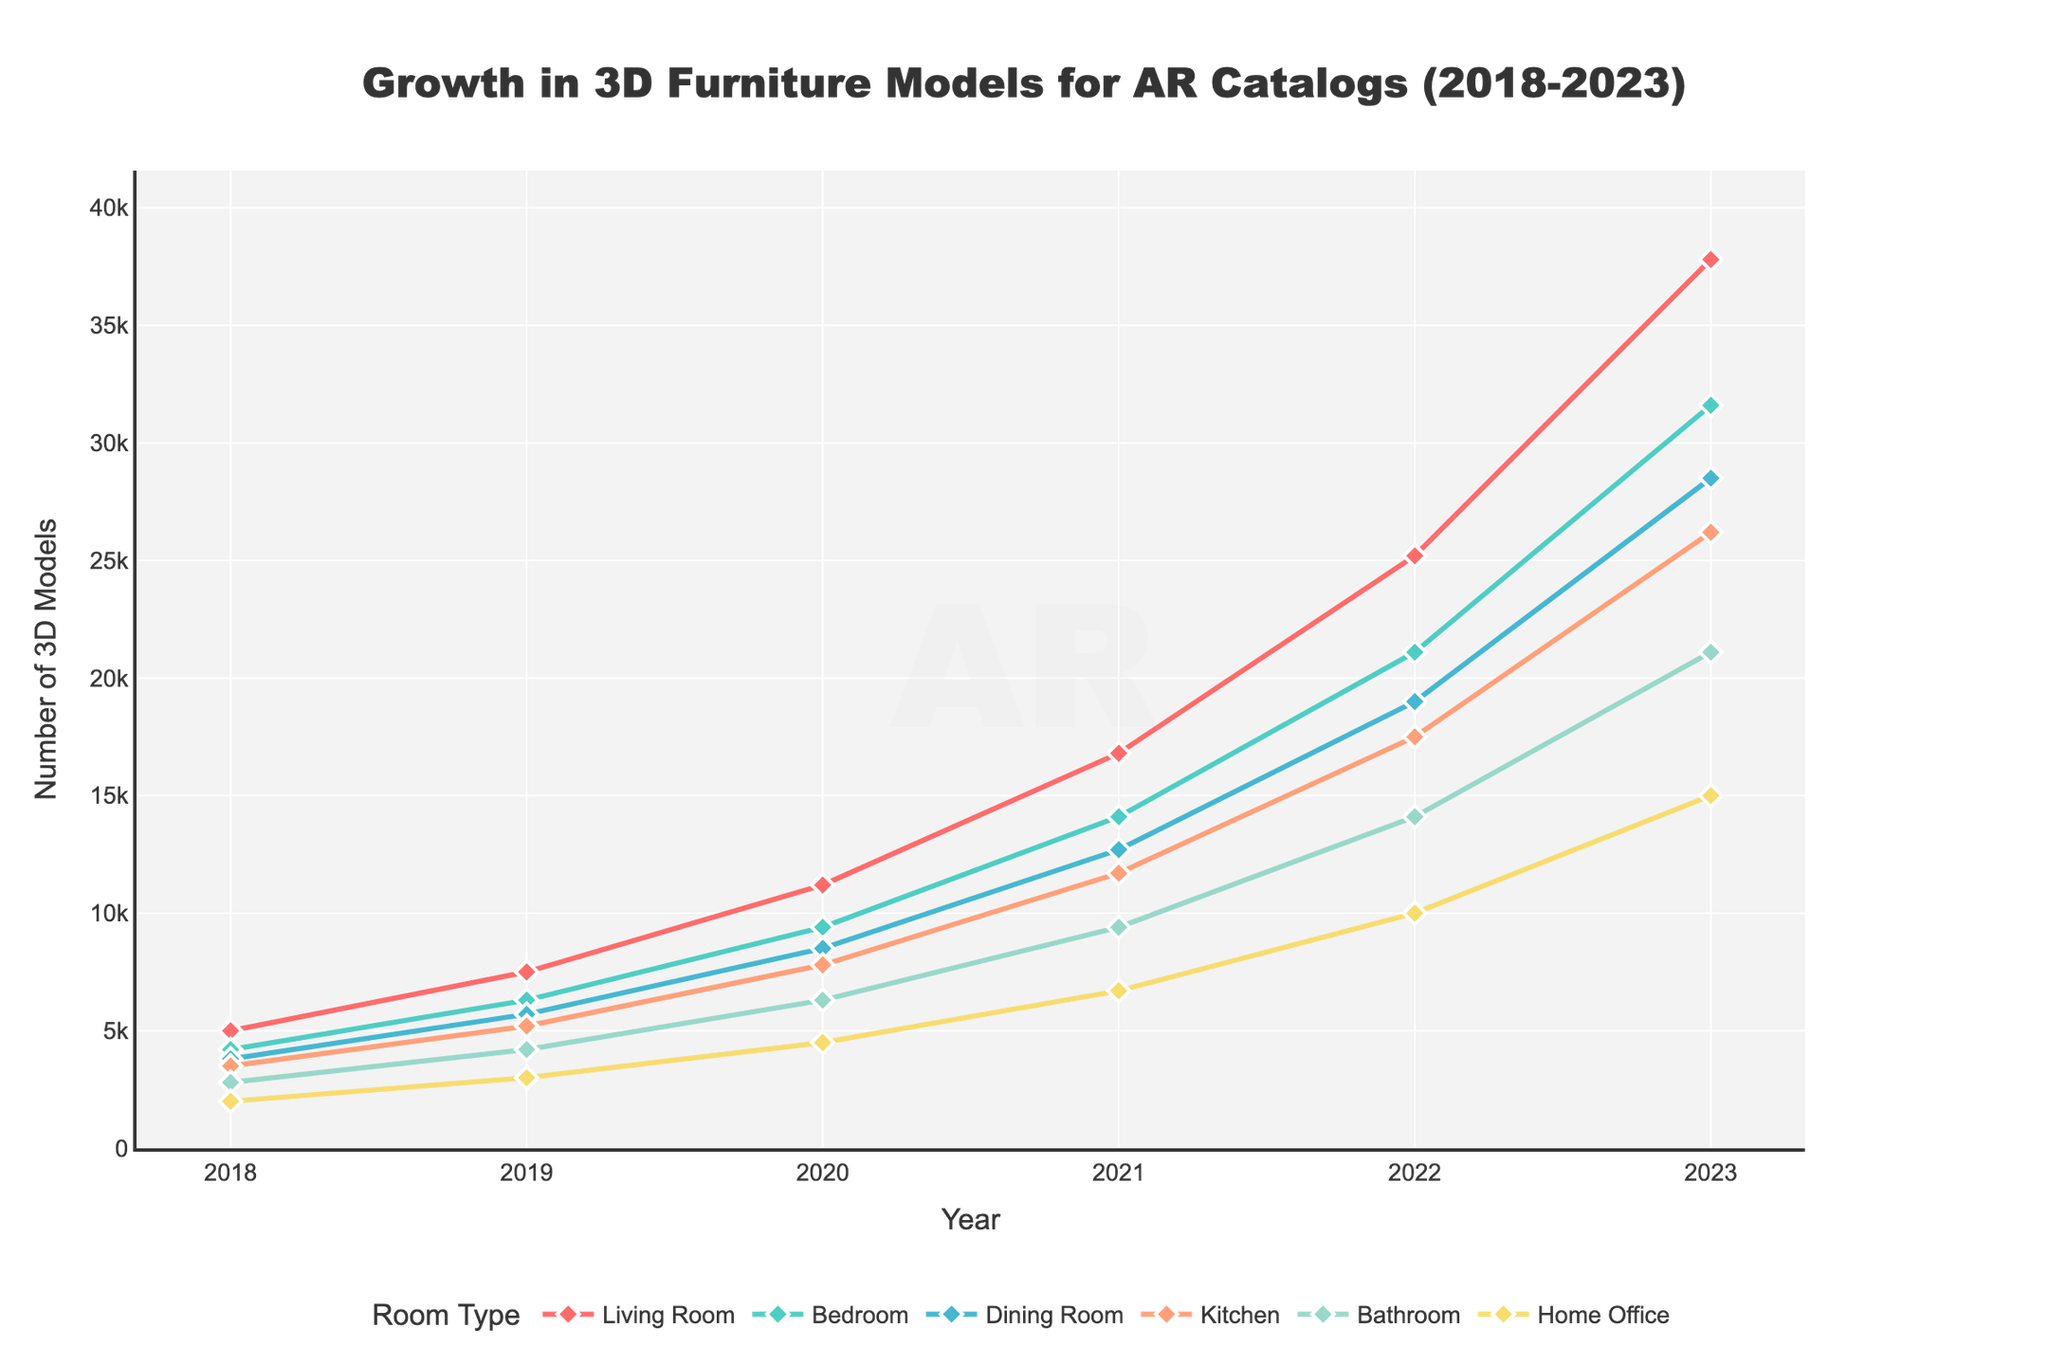What is the total increase in the number of 3D furniture models for the Living Room from 2018 to 2023? The number of 3D furniture models for the Living Room in 2018 is 5,000, and in 2023 it is 37,800. The total increase is 37,800 - 5,000 = 32,800.
Answer: 32,800 Which room type has the highest number of 3D furniture models in 2023? Looking at the values for 2023, the Living Room has the highest number with 37,800 models.
Answer: Living Room How much did the number of 3D furniture models for the Kitchen increase between 2020 and 2022? The number of Kitchen models in 2020 is 7,800 and in 2022 it is 17,500. The increase is 17,500 - 7,800 = 9,700.
Answer: 9,700 Which year saw the greatest increase in 3D furniture models for the Bedroom? By comparing the year-on-year increments: 2019-2018 (2,100), 2020-2019 (3,100), 2021-2020 (4,700), 2022-2021 (7,000), and 2023-2022 (10,500). The greatest increase occurred from 2022 to 2023 with 10,500 models.
Answer: 2022 to 2023 In 2021, which room type had the least number of 3D furniture models, and how many models were there? From the 2021 data, the Home Office had the least number with 6,700 models.
Answer: Home Office, 6,700 What is the average number of 3D furniture models across all room types in 2023? Sum the models: 37,800 (Living Room) + 31,600 (Bedroom) + 28,500 (Dining Room) + 26,200 (Kitchen) + 21,100 (Bathroom) + 15,000 (Home Office) = 160,200. The average is 160,200 / 6 = 26,700.
Answer: 26,700 Compare the growth of 3D models in the Bathroom between 2019 and 2021 with the growth in the Home Office during the same period. Which one grew more? Bathroom growth: 2021 (9,400) - 2019 (4,200) = 5,200. Home Office growth: 2021 (6,700) - 2019 (3,000) = 3,700. The Bathroom grew more by 5,200 - 3,700 = 1,500 models.
Answer: Bathroom grew more by 1,500 Which room type has shown the most consistent growth each year from 2018 to 2023? The Living Room has shown consistent and significant growth each year, with values steadily increasing from 5,000 in 2018 to 37,800 in 2023, without any fluctuation.
Answer: Living Room 